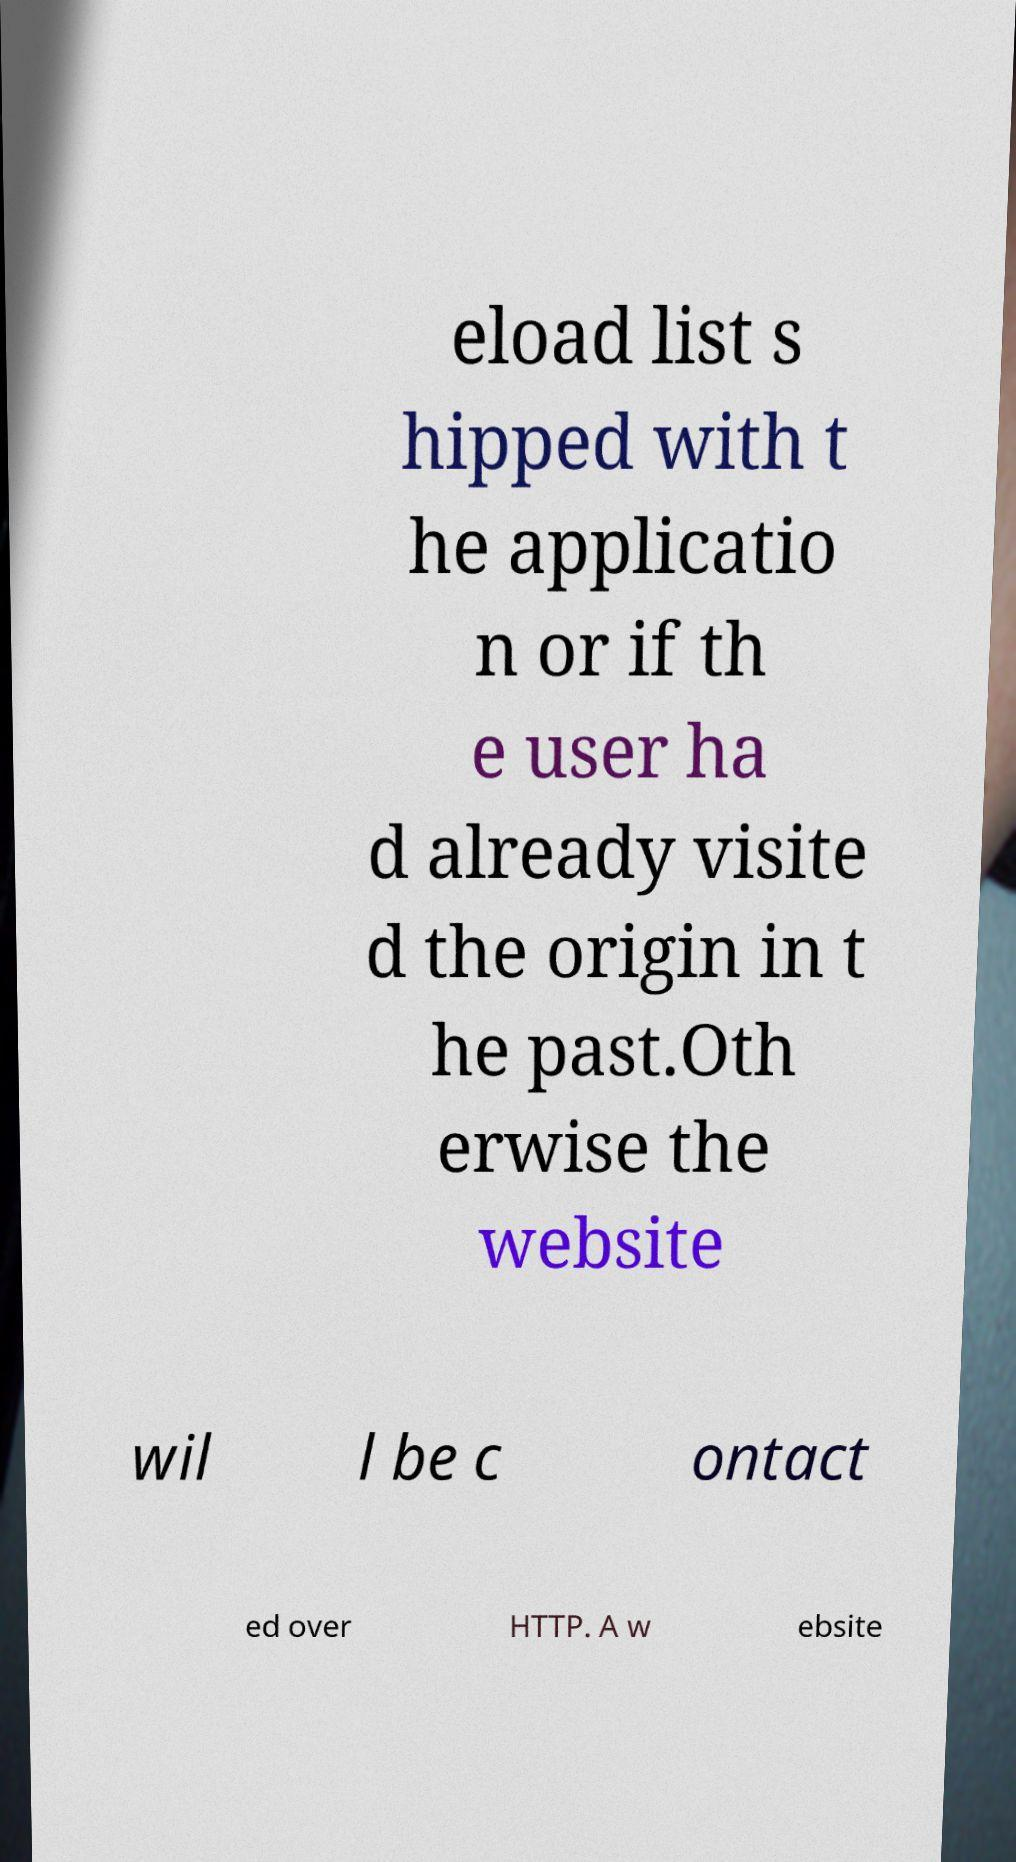There's text embedded in this image that I need extracted. Can you transcribe it verbatim? eload list s hipped with t he applicatio n or if th e user ha d already visite d the origin in t he past.Oth erwise the website wil l be c ontact ed over HTTP. A w ebsite 